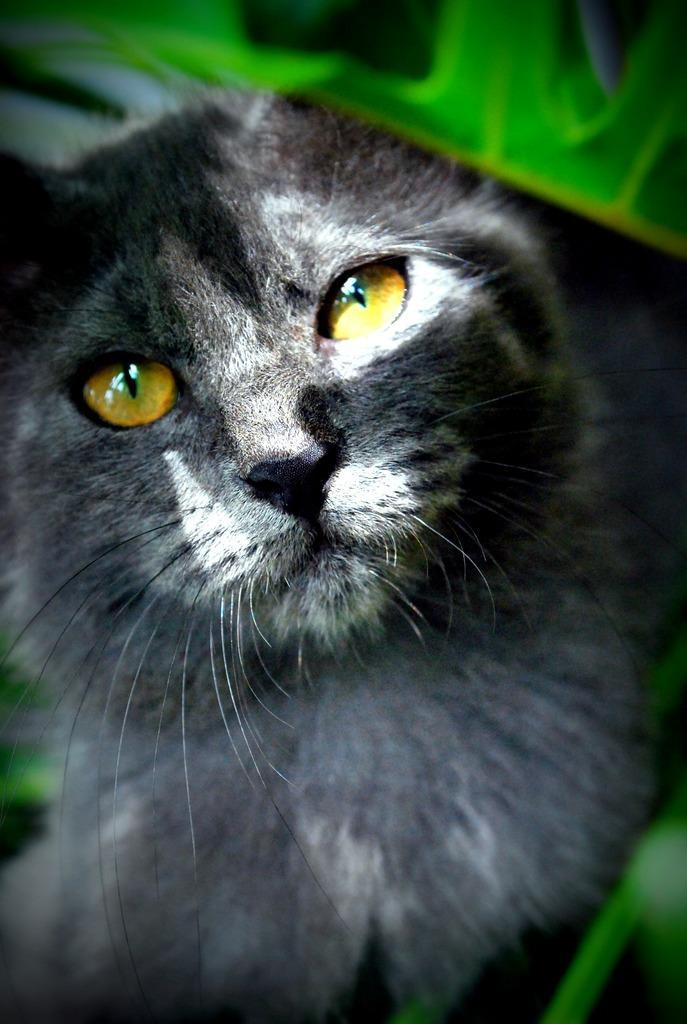How would you summarize this image in a sentence or two? In the foreground of this image, there is a black cat. On the top, there is green in color. 